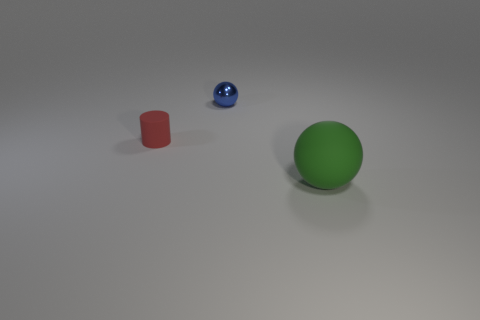Can you tell which object is the closest to the viewpoint? The green sphere is the closest object to the viewpoint. Its size relative to the other objects and the perspective of the image suggest it is positioned nearer to us than the red cylinder and the blue sphere. 